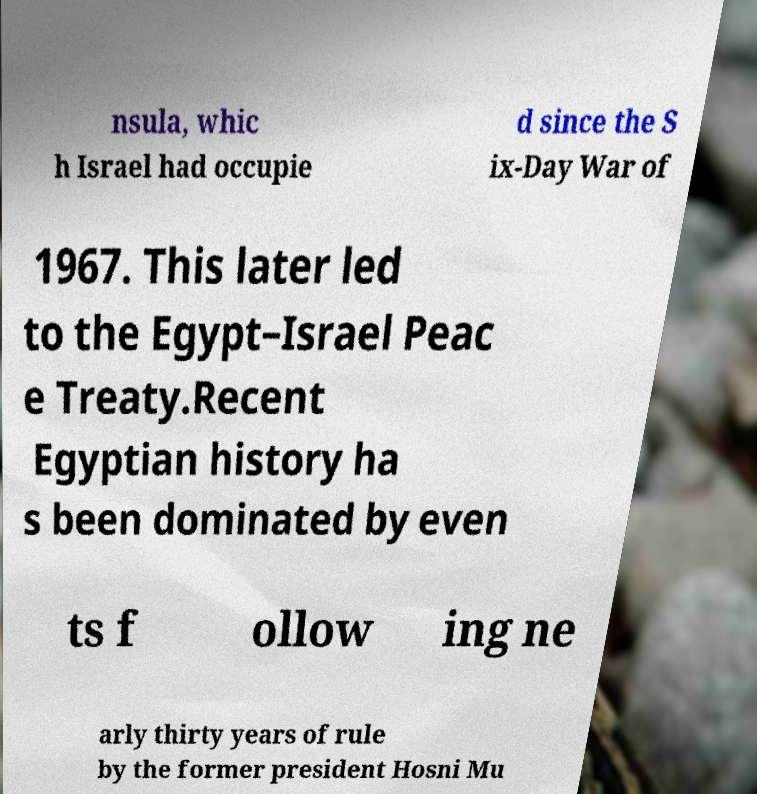Can you read and provide the text displayed in the image?This photo seems to have some interesting text. Can you extract and type it out for me? nsula, whic h Israel had occupie d since the S ix-Day War of 1967. This later led to the Egypt–Israel Peac e Treaty.Recent Egyptian history ha s been dominated by even ts f ollow ing ne arly thirty years of rule by the former president Hosni Mu 